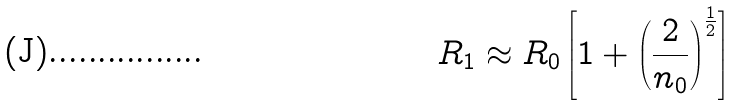<formula> <loc_0><loc_0><loc_500><loc_500>R _ { 1 } \approx R _ { 0 } \left [ 1 + \left ( \frac { 2 } { n _ { 0 } } \right ) ^ { \frac { 1 } { 2 } } \right ]</formula> 